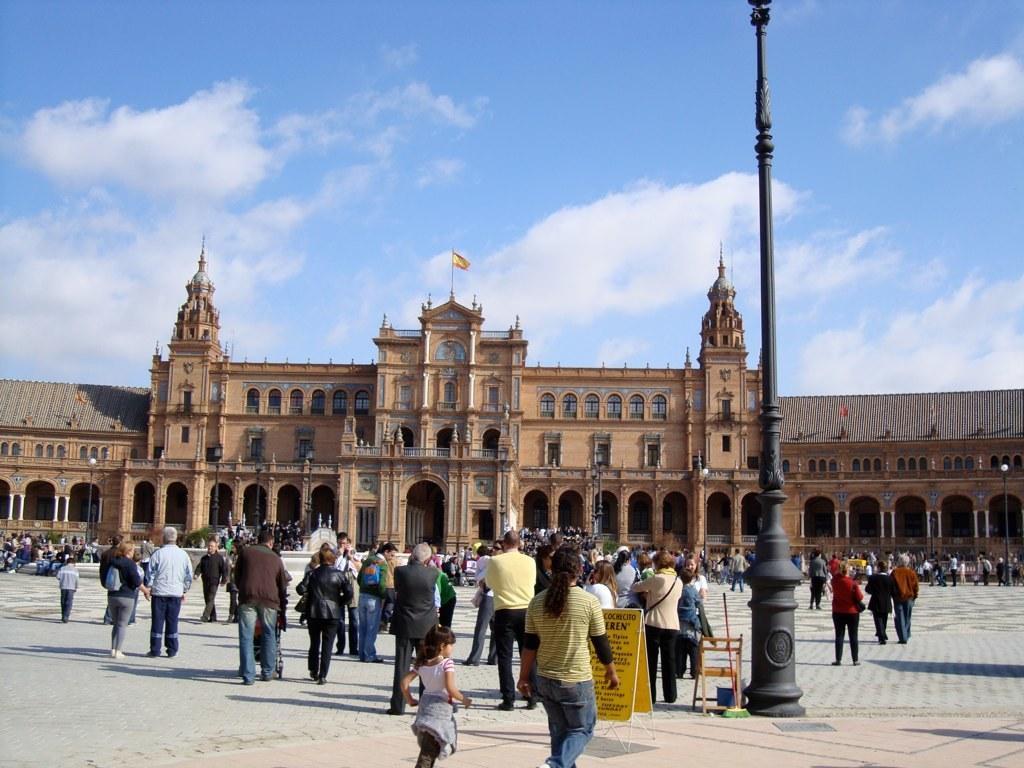Please provide a concise description of this image. In this picture we can see some people are walking, some people are standing and some people are sitting. In front of the people there is a board, a chair and poles. Behind the people there is a building and on the building there is a pole with a flag. Behind the building there is the sky. 